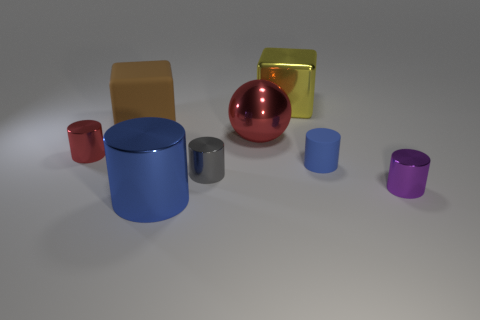Is the number of big brown cubes that are in front of the purple metal cylinder greater than the number of brown rubber cubes?
Offer a very short reply. No. Is there anything else of the same color as the sphere?
Your answer should be very brief. Yes. What is the shape of the red thing that is right of the small thing that is on the left side of the big brown cube?
Your response must be concise. Sphere. Are there more tiny green metallic spheres than spheres?
Your answer should be compact. No. What number of objects are both behind the big blue cylinder and on the left side of the purple thing?
Provide a succinct answer. 6. There is a small red metal thing that is on the left side of the big shiny cube; what number of red objects are behind it?
Offer a very short reply. 1. What number of things are either metal objects that are on the left side of the big brown matte thing or shiny objects to the right of the large brown rubber block?
Offer a very short reply. 6. There is another big thing that is the same shape as the purple metallic object; what is its material?
Your answer should be very brief. Metal. What number of things are large things that are behind the small red metallic thing or tiny metal cylinders?
Offer a terse response. 6. What is the shape of the blue thing that is made of the same material as the large red thing?
Give a very brief answer. Cylinder. 